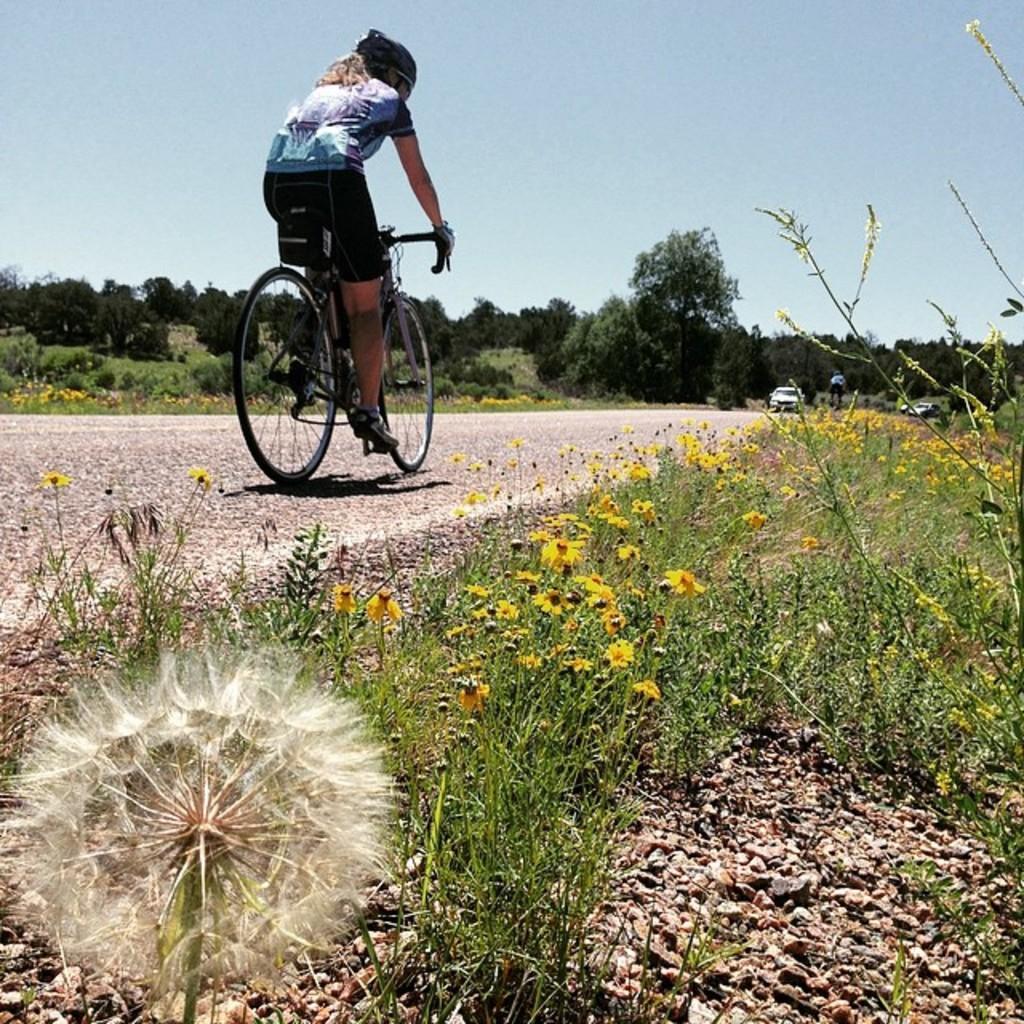How would you summarize this image in a sentence or two? In this picture I can see the flowers and plants at the bottom, in the middle a person is riding the bicycle. On the right side I can see the vehicles, in the background there are trees. At the top I can see the sky. 